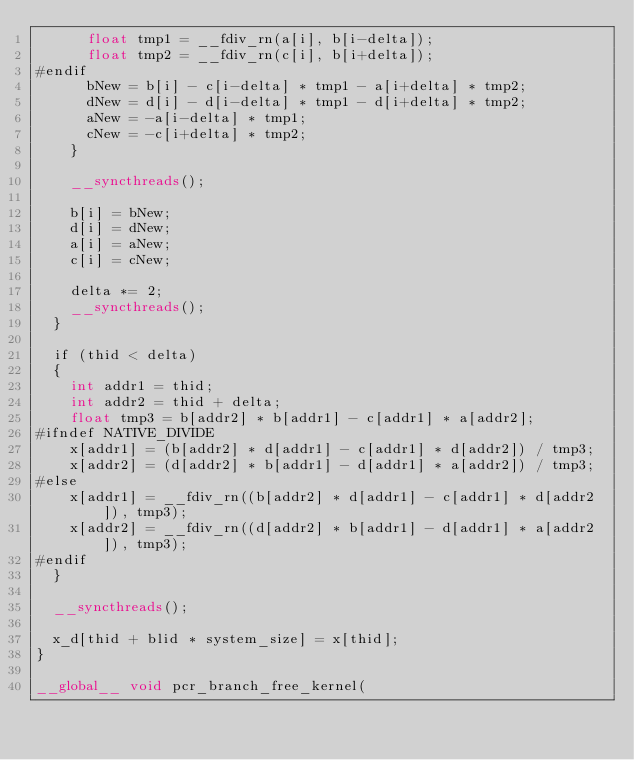<code> <loc_0><loc_0><loc_500><loc_500><_Cuda_>      float tmp1 = __fdiv_rn(a[i], b[i-delta]);
      float tmp2 = __fdiv_rn(c[i], b[i+delta]);
#endif
      bNew = b[i] - c[i-delta] * tmp1 - a[i+delta] * tmp2;
      dNew = d[i] - d[i-delta] * tmp1 - d[i+delta] * tmp2;
      aNew = -a[i-delta] * tmp1;
      cNew = -c[i+delta] * tmp2;
    }

    __syncthreads();

    b[i] = bNew;
    d[i] = dNew;
    a[i] = aNew;
    c[i] = cNew;  

    delta *= 2;
    __syncthreads();
  }

  if (thid < delta)
  {
    int addr1 = thid;
    int addr2 = thid + delta;
    float tmp3 = b[addr2] * b[addr1] - c[addr1] * a[addr2];
#ifndef NATIVE_DIVIDE
    x[addr1] = (b[addr2] * d[addr1] - c[addr1] * d[addr2]) / tmp3;
    x[addr2] = (d[addr2] * b[addr1] - d[addr1] * a[addr2]) / tmp3;
#else
    x[addr1] = __fdiv_rn((b[addr2] * d[addr1] - c[addr1] * d[addr2]), tmp3);
    x[addr2] = __fdiv_rn((d[addr2] * b[addr1] - d[addr1] * a[addr2]), tmp3);
#endif
  }

  __syncthreads();

  x_d[thid + blid * system_size] = x[thid];
}

__global__ void pcr_branch_free_kernel(</code> 